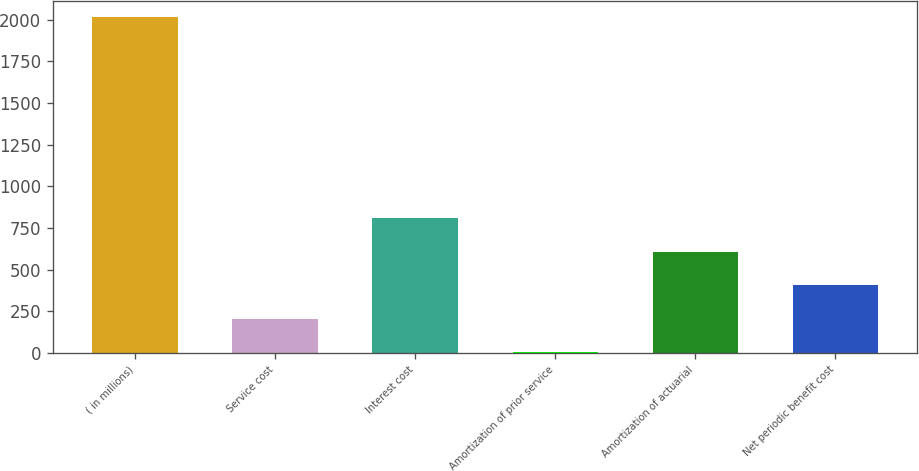<chart> <loc_0><loc_0><loc_500><loc_500><bar_chart><fcel>( in millions)<fcel>Service cost<fcel>Interest cost<fcel>Amortization of prior service<fcel>Amortization of actuarial<fcel>Net periodic benefit cost<nl><fcel>2014<fcel>203.2<fcel>806.8<fcel>2<fcel>605.6<fcel>404.4<nl></chart> 